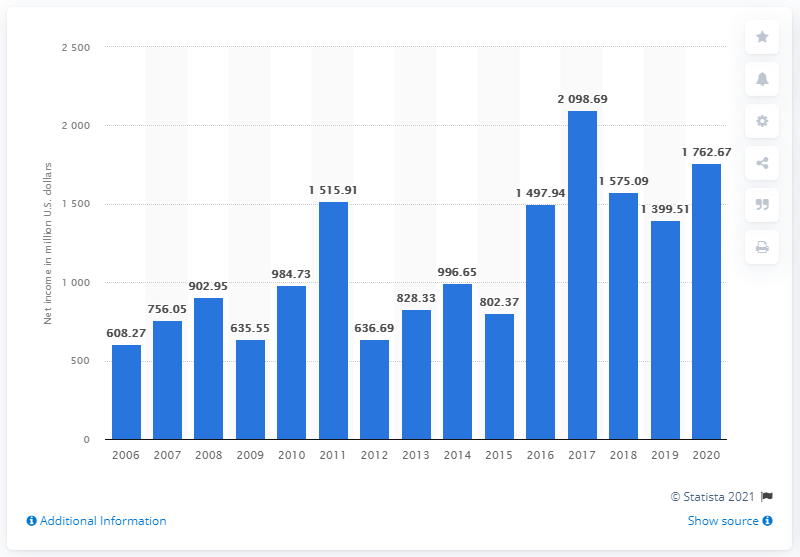Outline some significant characteristics in this image. The net earnings of Dish Network in the previous year were 1,399.51. 